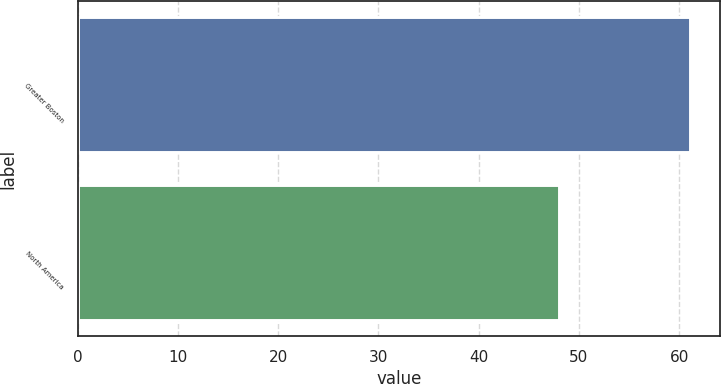<chart> <loc_0><loc_0><loc_500><loc_500><bar_chart><fcel>Greater Boston<fcel>North America<nl><fcel>61.05<fcel>48.01<nl></chart> 